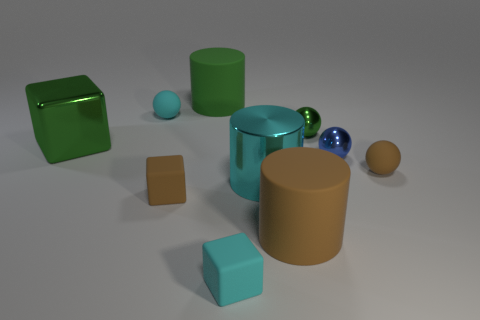There is a shiny block; is it the same color as the large rubber cylinder that is behind the tiny cyan ball?
Keep it short and to the point. Yes. Do the brown sphere and the tiny cyan cube have the same material?
Provide a short and direct response. Yes. Is there a object that has the same size as the brown matte cylinder?
Your answer should be compact. Yes. What is the material of the brown thing that is the same size as the green rubber cylinder?
Your response must be concise. Rubber. Are there any large brown objects that have the same shape as the cyan shiny object?
Offer a terse response. Yes. What is the material of the cylinder that is the same color as the big cube?
Provide a short and direct response. Rubber. What is the shape of the tiny cyan object in front of the cyan metallic cylinder?
Give a very brief answer. Cube. What number of metal things are there?
Keep it short and to the point. 4. There is a ball that is the same material as the blue thing; what is its color?
Offer a terse response. Green. How many small objects are either green cubes or shiny cylinders?
Ensure brevity in your answer.  0. 